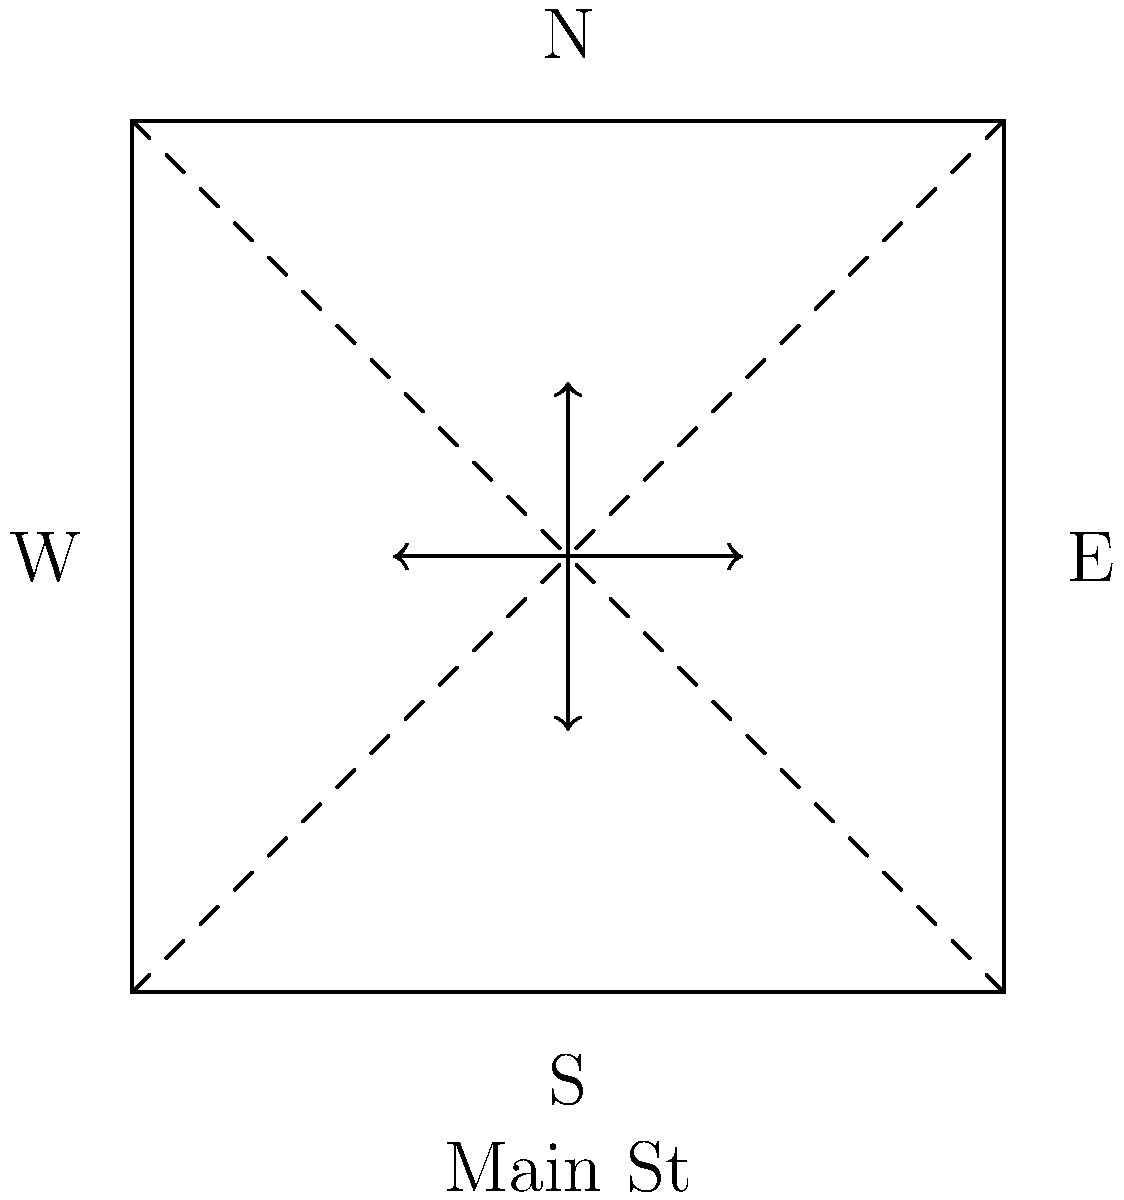At a busy intersection of Main Street and Oak Avenue, traffic flow optimization is crucial. Given the bird's-eye view diagram, which traffic light phase would be most efficient to reduce wait times and prevent potential neural stress for drivers, assuming equal traffic volume in all directions? To optimize traffic flow and reduce wait times, we need to consider the following steps:

1. Analyze the intersection layout:
   - The diagram shows a four-way intersection with potential conflicts at the center.

2. Consider traffic movement patterns:
   - Straight movements in opposite directions don't conflict.
   - Left turns conflict with oncoming straight traffic and opposing left turns.

3. Evaluate potential phases:
   a) Allow all directions simultaneously (high risk of collisions).
   b) Alternate between north-south and east-west directions (simple but less efficient).
   c) Use a four-phase system (safe but increases wait times).
   d) Implement a two-phase system with protected left turns.

4. Optimal solution:
   The most efficient phase would be a two-phase system with protected left turns:
   - Phase 1: North-south straight traffic and left turns.
   - Phase 2: East-west straight traffic and left turns.

5. Benefits of this system:
   - Reduces wait times by allowing simultaneous straight and left-turn movements.
   - Prevents conflicts between left-turning vehicles and oncoming traffic.
   - Minimizes the number of phases, reducing overall cycle length.
   - Provides a predictable and less stressful experience for drivers.

This solution balances safety and efficiency, potentially reducing neural stress for drivers by minimizing unpredictable traffic patterns and long wait times.
Answer: Two-phase system with protected left turns 